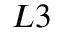Convert formula to latex. <formula><loc_0><loc_0><loc_500><loc_500>L 3</formula> 